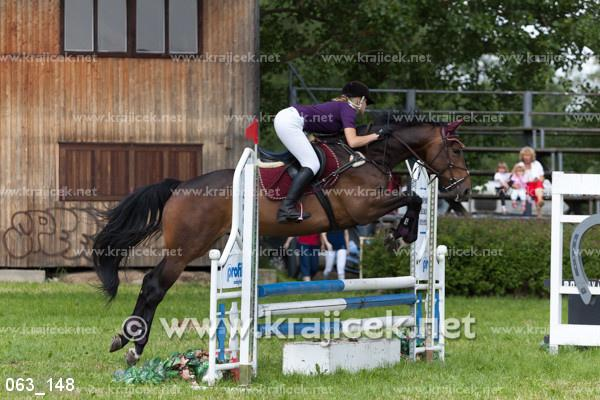What activity is the horse shown here taking part in? Please explain your reasoning. steeple chase. The activity is steeplechase. 